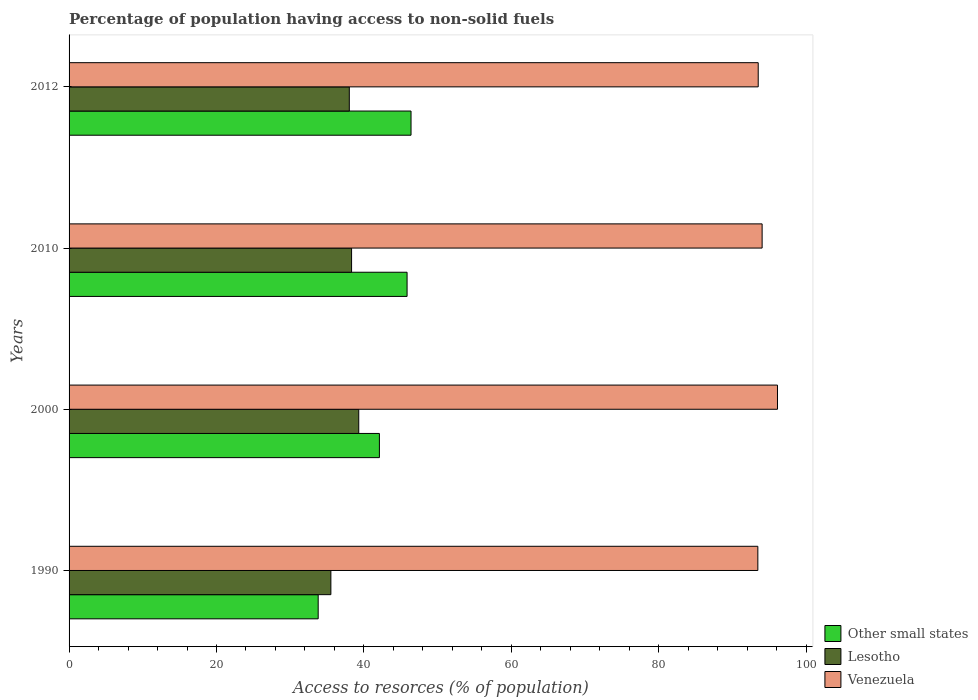Are the number of bars on each tick of the Y-axis equal?
Your answer should be compact. Yes. How many bars are there on the 2nd tick from the top?
Ensure brevity in your answer.  3. What is the label of the 4th group of bars from the top?
Give a very brief answer. 1990. In how many cases, is the number of bars for a given year not equal to the number of legend labels?
Give a very brief answer. 0. What is the percentage of population having access to non-solid fuels in Venezuela in 1990?
Offer a very short reply. 93.45. Across all years, what is the maximum percentage of population having access to non-solid fuels in Venezuela?
Offer a terse response. 96.12. Across all years, what is the minimum percentage of population having access to non-solid fuels in Venezuela?
Keep it short and to the point. 93.45. What is the total percentage of population having access to non-solid fuels in Lesotho in the graph?
Your answer should be very brief. 151.18. What is the difference between the percentage of population having access to non-solid fuels in Venezuela in 2010 and that in 2012?
Provide a succinct answer. 0.53. What is the difference between the percentage of population having access to non-solid fuels in Other small states in 2000 and the percentage of population having access to non-solid fuels in Venezuela in 2012?
Your answer should be compact. -51.4. What is the average percentage of population having access to non-solid fuels in Other small states per year?
Your answer should be very brief. 42.04. In the year 2012, what is the difference between the percentage of population having access to non-solid fuels in Venezuela and percentage of population having access to non-solid fuels in Lesotho?
Your answer should be compact. 55.48. In how many years, is the percentage of population having access to non-solid fuels in Other small states greater than 88 %?
Ensure brevity in your answer.  0. What is the ratio of the percentage of population having access to non-solid fuels in Venezuela in 1990 to that in 2012?
Make the answer very short. 1. Is the difference between the percentage of population having access to non-solid fuels in Venezuela in 1990 and 2010 greater than the difference between the percentage of population having access to non-solid fuels in Lesotho in 1990 and 2010?
Provide a short and direct response. Yes. What is the difference between the highest and the second highest percentage of population having access to non-solid fuels in Venezuela?
Give a very brief answer. 2.08. What is the difference between the highest and the lowest percentage of population having access to non-solid fuels in Other small states?
Offer a very short reply. 12.6. Is the sum of the percentage of population having access to non-solid fuels in Other small states in 1990 and 2012 greater than the maximum percentage of population having access to non-solid fuels in Lesotho across all years?
Offer a terse response. Yes. What does the 1st bar from the top in 1990 represents?
Ensure brevity in your answer.  Venezuela. What does the 2nd bar from the bottom in 2012 represents?
Give a very brief answer. Lesotho. How many bars are there?
Offer a terse response. 12. How many years are there in the graph?
Your answer should be very brief. 4. What is the difference between two consecutive major ticks on the X-axis?
Offer a terse response. 20. Are the values on the major ticks of X-axis written in scientific E-notation?
Ensure brevity in your answer.  No. Does the graph contain any zero values?
Ensure brevity in your answer.  No. Where does the legend appear in the graph?
Provide a short and direct response. Bottom right. How are the legend labels stacked?
Provide a short and direct response. Vertical. What is the title of the graph?
Offer a very short reply. Percentage of population having access to non-solid fuels. Does "Slovak Republic" appear as one of the legend labels in the graph?
Give a very brief answer. No. What is the label or title of the X-axis?
Your answer should be compact. Access to resorces (% of population). What is the Access to resorces (% of population) of Other small states in 1990?
Give a very brief answer. 33.8. What is the Access to resorces (% of population) in Lesotho in 1990?
Your answer should be compact. 35.52. What is the Access to resorces (% of population) in Venezuela in 1990?
Your answer should be compact. 93.45. What is the Access to resorces (% of population) in Other small states in 2000?
Offer a very short reply. 42.11. What is the Access to resorces (% of population) of Lesotho in 2000?
Make the answer very short. 39.3. What is the Access to resorces (% of population) of Venezuela in 2000?
Ensure brevity in your answer.  96.12. What is the Access to resorces (% of population) of Other small states in 2010?
Make the answer very short. 45.86. What is the Access to resorces (% of population) of Lesotho in 2010?
Ensure brevity in your answer.  38.33. What is the Access to resorces (% of population) in Venezuela in 2010?
Offer a terse response. 94.03. What is the Access to resorces (% of population) in Other small states in 2012?
Ensure brevity in your answer.  46.4. What is the Access to resorces (% of population) in Lesotho in 2012?
Make the answer very short. 38.02. What is the Access to resorces (% of population) in Venezuela in 2012?
Provide a succinct answer. 93.5. Across all years, what is the maximum Access to resorces (% of population) in Other small states?
Give a very brief answer. 46.4. Across all years, what is the maximum Access to resorces (% of population) in Lesotho?
Your answer should be very brief. 39.3. Across all years, what is the maximum Access to resorces (% of population) of Venezuela?
Make the answer very short. 96.12. Across all years, what is the minimum Access to resorces (% of population) in Other small states?
Give a very brief answer. 33.8. Across all years, what is the minimum Access to resorces (% of population) in Lesotho?
Your response must be concise. 35.52. Across all years, what is the minimum Access to resorces (% of population) in Venezuela?
Keep it short and to the point. 93.45. What is the total Access to resorces (% of population) in Other small states in the graph?
Keep it short and to the point. 168.16. What is the total Access to resorces (% of population) in Lesotho in the graph?
Your response must be concise. 151.18. What is the total Access to resorces (% of population) of Venezuela in the graph?
Offer a terse response. 377.1. What is the difference between the Access to resorces (% of population) in Other small states in 1990 and that in 2000?
Make the answer very short. -8.31. What is the difference between the Access to resorces (% of population) in Lesotho in 1990 and that in 2000?
Your response must be concise. -3.78. What is the difference between the Access to resorces (% of population) of Venezuela in 1990 and that in 2000?
Provide a short and direct response. -2.66. What is the difference between the Access to resorces (% of population) of Other small states in 1990 and that in 2010?
Your answer should be very brief. -12.06. What is the difference between the Access to resorces (% of population) in Lesotho in 1990 and that in 2010?
Give a very brief answer. -2.81. What is the difference between the Access to resorces (% of population) in Venezuela in 1990 and that in 2010?
Your answer should be compact. -0.58. What is the difference between the Access to resorces (% of population) of Other small states in 1990 and that in 2012?
Provide a short and direct response. -12.6. What is the difference between the Access to resorces (% of population) in Lesotho in 1990 and that in 2012?
Your answer should be compact. -2.5. What is the difference between the Access to resorces (% of population) of Venezuela in 1990 and that in 2012?
Your response must be concise. -0.05. What is the difference between the Access to resorces (% of population) in Other small states in 2000 and that in 2010?
Provide a short and direct response. -3.75. What is the difference between the Access to resorces (% of population) in Lesotho in 2000 and that in 2010?
Offer a terse response. 0.97. What is the difference between the Access to resorces (% of population) in Venezuela in 2000 and that in 2010?
Provide a short and direct response. 2.08. What is the difference between the Access to resorces (% of population) of Other small states in 2000 and that in 2012?
Give a very brief answer. -4.29. What is the difference between the Access to resorces (% of population) in Lesotho in 2000 and that in 2012?
Your response must be concise. 1.28. What is the difference between the Access to resorces (% of population) of Venezuela in 2000 and that in 2012?
Make the answer very short. 2.61. What is the difference between the Access to resorces (% of population) of Other small states in 2010 and that in 2012?
Keep it short and to the point. -0.54. What is the difference between the Access to resorces (% of population) in Lesotho in 2010 and that in 2012?
Provide a short and direct response. 0.31. What is the difference between the Access to resorces (% of population) of Venezuela in 2010 and that in 2012?
Keep it short and to the point. 0.53. What is the difference between the Access to resorces (% of population) in Other small states in 1990 and the Access to resorces (% of population) in Lesotho in 2000?
Offer a very short reply. -5.5. What is the difference between the Access to resorces (% of population) in Other small states in 1990 and the Access to resorces (% of population) in Venezuela in 2000?
Ensure brevity in your answer.  -62.32. What is the difference between the Access to resorces (% of population) of Lesotho in 1990 and the Access to resorces (% of population) of Venezuela in 2000?
Your answer should be very brief. -60.59. What is the difference between the Access to resorces (% of population) in Other small states in 1990 and the Access to resorces (% of population) in Lesotho in 2010?
Ensure brevity in your answer.  -4.53. What is the difference between the Access to resorces (% of population) in Other small states in 1990 and the Access to resorces (% of population) in Venezuela in 2010?
Provide a short and direct response. -60.23. What is the difference between the Access to resorces (% of population) in Lesotho in 1990 and the Access to resorces (% of population) in Venezuela in 2010?
Make the answer very short. -58.51. What is the difference between the Access to resorces (% of population) of Other small states in 1990 and the Access to resorces (% of population) of Lesotho in 2012?
Keep it short and to the point. -4.22. What is the difference between the Access to resorces (% of population) in Other small states in 1990 and the Access to resorces (% of population) in Venezuela in 2012?
Ensure brevity in your answer.  -59.7. What is the difference between the Access to resorces (% of population) of Lesotho in 1990 and the Access to resorces (% of population) of Venezuela in 2012?
Give a very brief answer. -57.98. What is the difference between the Access to resorces (% of population) of Other small states in 2000 and the Access to resorces (% of population) of Lesotho in 2010?
Offer a terse response. 3.78. What is the difference between the Access to resorces (% of population) in Other small states in 2000 and the Access to resorces (% of population) in Venezuela in 2010?
Your answer should be compact. -51.93. What is the difference between the Access to resorces (% of population) of Lesotho in 2000 and the Access to resorces (% of population) of Venezuela in 2010?
Make the answer very short. -54.73. What is the difference between the Access to resorces (% of population) in Other small states in 2000 and the Access to resorces (% of population) in Lesotho in 2012?
Provide a short and direct response. 4.08. What is the difference between the Access to resorces (% of population) in Other small states in 2000 and the Access to resorces (% of population) in Venezuela in 2012?
Offer a terse response. -51.4. What is the difference between the Access to resorces (% of population) in Lesotho in 2000 and the Access to resorces (% of population) in Venezuela in 2012?
Provide a short and direct response. -54.2. What is the difference between the Access to resorces (% of population) in Other small states in 2010 and the Access to resorces (% of population) in Lesotho in 2012?
Offer a terse response. 7.84. What is the difference between the Access to resorces (% of population) of Other small states in 2010 and the Access to resorces (% of population) of Venezuela in 2012?
Keep it short and to the point. -47.64. What is the difference between the Access to resorces (% of population) in Lesotho in 2010 and the Access to resorces (% of population) in Venezuela in 2012?
Provide a succinct answer. -55.17. What is the average Access to resorces (% of population) in Other small states per year?
Your answer should be compact. 42.04. What is the average Access to resorces (% of population) in Lesotho per year?
Provide a succinct answer. 37.79. What is the average Access to resorces (% of population) in Venezuela per year?
Offer a terse response. 94.28. In the year 1990, what is the difference between the Access to resorces (% of population) in Other small states and Access to resorces (% of population) in Lesotho?
Give a very brief answer. -1.72. In the year 1990, what is the difference between the Access to resorces (% of population) in Other small states and Access to resorces (% of population) in Venezuela?
Give a very brief answer. -59.65. In the year 1990, what is the difference between the Access to resorces (% of population) in Lesotho and Access to resorces (% of population) in Venezuela?
Make the answer very short. -57.93. In the year 2000, what is the difference between the Access to resorces (% of population) of Other small states and Access to resorces (% of population) of Lesotho?
Offer a very short reply. 2.8. In the year 2000, what is the difference between the Access to resorces (% of population) in Other small states and Access to resorces (% of population) in Venezuela?
Make the answer very short. -54.01. In the year 2000, what is the difference between the Access to resorces (% of population) of Lesotho and Access to resorces (% of population) of Venezuela?
Keep it short and to the point. -56.81. In the year 2010, what is the difference between the Access to resorces (% of population) of Other small states and Access to resorces (% of population) of Lesotho?
Your response must be concise. 7.53. In the year 2010, what is the difference between the Access to resorces (% of population) of Other small states and Access to resorces (% of population) of Venezuela?
Offer a terse response. -48.17. In the year 2010, what is the difference between the Access to resorces (% of population) of Lesotho and Access to resorces (% of population) of Venezuela?
Give a very brief answer. -55.7. In the year 2012, what is the difference between the Access to resorces (% of population) in Other small states and Access to resorces (% of population) in Lesotho?
Ensure brevity in your answer.  8.37. In the year 2012, what is the difference between the Access to resorces (% of population) of Other small states and Access to resorces (% of population) of Venezuela?
Your answer should be compact. -47.11. In the year 2012, what is the difference between the Access to resorces (% of population) in Lesotho and Access to resorces (% of population) in Venezuela?
Give a very brief answer. -55.48. What is the ratio of the Access to resorces (% of population) of Other small states in 1990 to that in 2000?
Offer a very short reply. 0.8. What is the ratio of the Access to resorces (% of population) in Lesotho in 1990 to that in 2000?
Your answer should be compact. 0.9. What is the ratio of the Access to resorces (% of population) of Venezuela in 1990 to that in 2000?
Your answer should be very brief. 0.97. What is the ratio of the Access to resorces (% of population) of Other small states in 1990 to that in 2010?
Provide a succinct answer. 0.74. What is the ratio of the Access to resorces (% of population) in Lesotho in 1990 to that in 2010?
Make the answer very short. 0.93. What is the ratio of the Access to resorces (% of population) of Venezuela in 1990 to that in 2010?
Keep it short and to the point. 0.99. What is the ratio of the Access to resorces (% of population) in Other small states in 1990 to that in 2012?
Your answer should be compact. 0.73. What is the ratio of the Access to resorces (% of population) of Lesotho in 1990 to that in 2012?
Ensure brevity in your answer.  0.93. What is the ratio of the Access to resorces (% of population) of Venezuela in 1990 to that in 2012?
Give a very brief answer. 1. What is the ratio of the Access to resorces (% of population) in Other small states in 2000 to that in 2010?
Keep it short and to the point. 0.92. What is the ratio of the Access to resorces (% of population) of Lesotho in 2000 to that in 2010?
Your response must be concise. 1.03. What is the ratio of the Access to resorces (% of population) in Venezuela in 2000 to that in 2010?
Give a very brief answer. 1.02. What is the ratio of the Access to resorces (% of population) in Other small states in 2000 to that in 2012?
Your response must be concise. 0.91. What is the ratio of the Access to resorces (% of population) in Lesotho in 2000 to that in 2012?
Ensure brevity in your answer.  1.03. What is the ratio of the Access to resorces (% of population) of Venezuela in 2000 to that in 2012?
Make the answer very short. 1.03. What is the ratio of the Access to resorces (% of population) of Other small states in 2010 to that in 2012?
Your answer should be compact. 0.99. What is the ratio of the Access to resorces (% of population) of Lesotho in 2010 to that in 2012?
Ensure brevity in your answer.  1.01. What is the ratio of the Access to resorces (% of population) in Venezuela in 2010 to that in 2012?
Provide a short and direct response. 1.01. What is the difference between the highest and the second highest Access to resorces (% of population) of Other small states?
Your response must be concise. 0.54. What is the difference between the highest and the second highest Access to resorces (% of population) in Lesotho?
Ensure brevity in your answer.  0.97. What is the difference between the highest and the second highest Access to resorces (% of population) in Venezuela?
Give a very brief answer. 2.08. What is the difference between the highest and the lowest Access to resorces (% of population) in Other small states?
Offer a very short reply. 12.6. What is the difference between the highest and the lowest Access to resorces (% of population) in Lesotho?
Give a very brief answer. 3.78. What is the difference between the highest and the lowest Access to resorces (% of population) in Venezuela?
Ensure brevity in your answer.  2.66. 